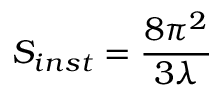Convert formula to latex. <formula><loc_0><loc_0><loc_500><loc_500>S _ { i n s t } = { \frac { 8 \pi ^ { 2 } } { 3 \lambda } }</formula> 